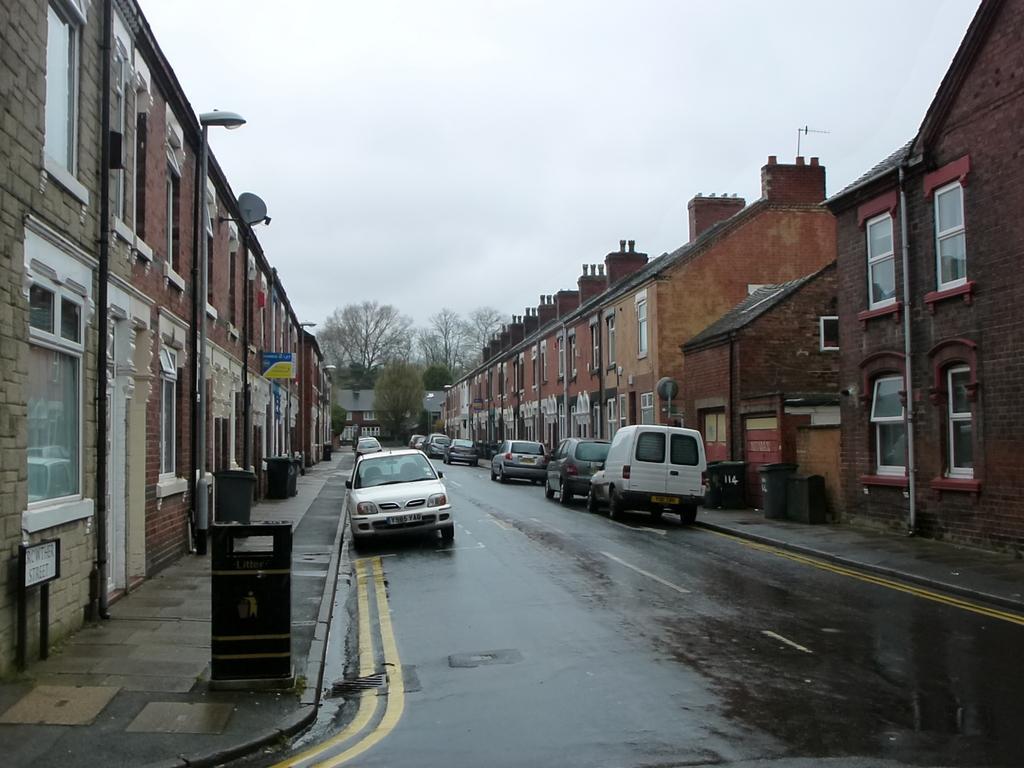Describe this image in one or two sentences. At the top portion of the picture we can see the sky. In the background we can see trees. In this picture we can see buildings, windows, boards. We can see vehicles on the road. There are trash cans near to the buildings. 